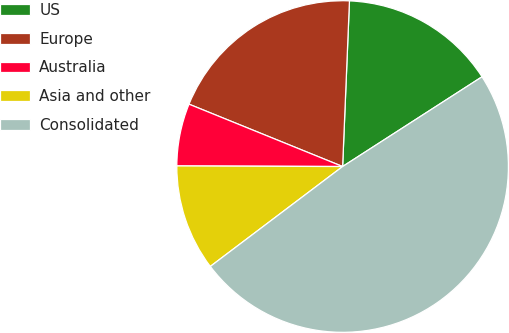Convert chart to OTSL. <chart><loc_0><loc_0><loc_500><loc_500><pie_chart><fcel>US<fcel>Europe<fcel>Australia<fcel>Asia and other<fcel>Consolidated<nl><fcel>15.24%<fcel>19.52%<fcel>6.08%<fcel>10.35%<fcel>48.81%<nl></chart> 